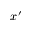<formula> <loc_0><loc_0><loc_500><loc_500>x ^ { \prime }</formula> 